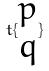<formula> <loc_0><loc_0><loc_500><loc_500>t \{ \begin{matrix} p \\ q \end{matrix} \}</formula> 